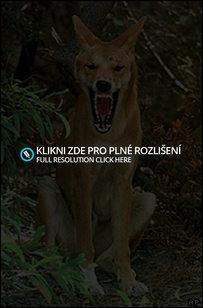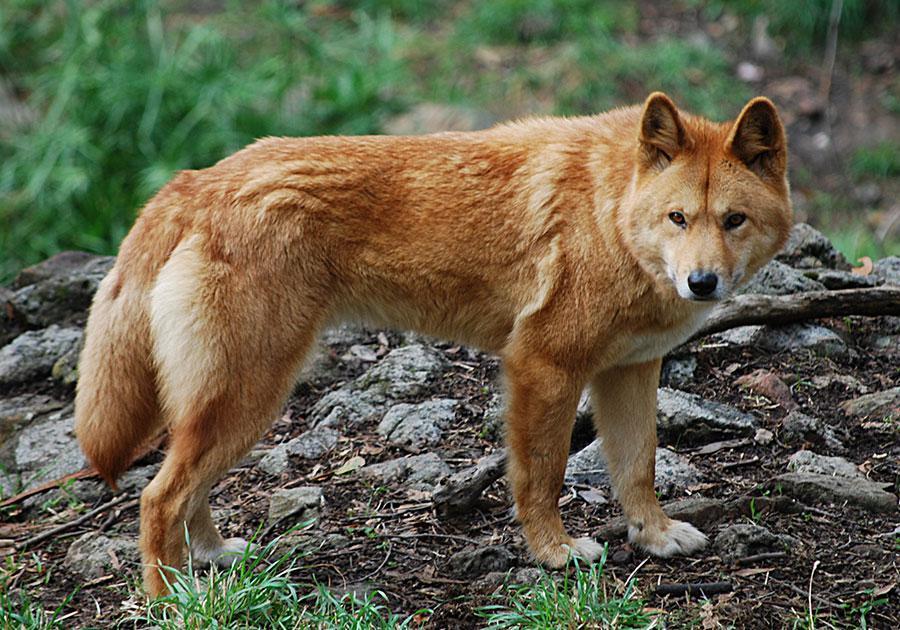The first image is the image on the left, the second image is the image on the right. For the images displayed, is the sentence "The left image shows one reclining dog with extened front paws and upright head, and the right image shows one orange dingo gazing leftward." factually correct? Answer yes or no. No. 